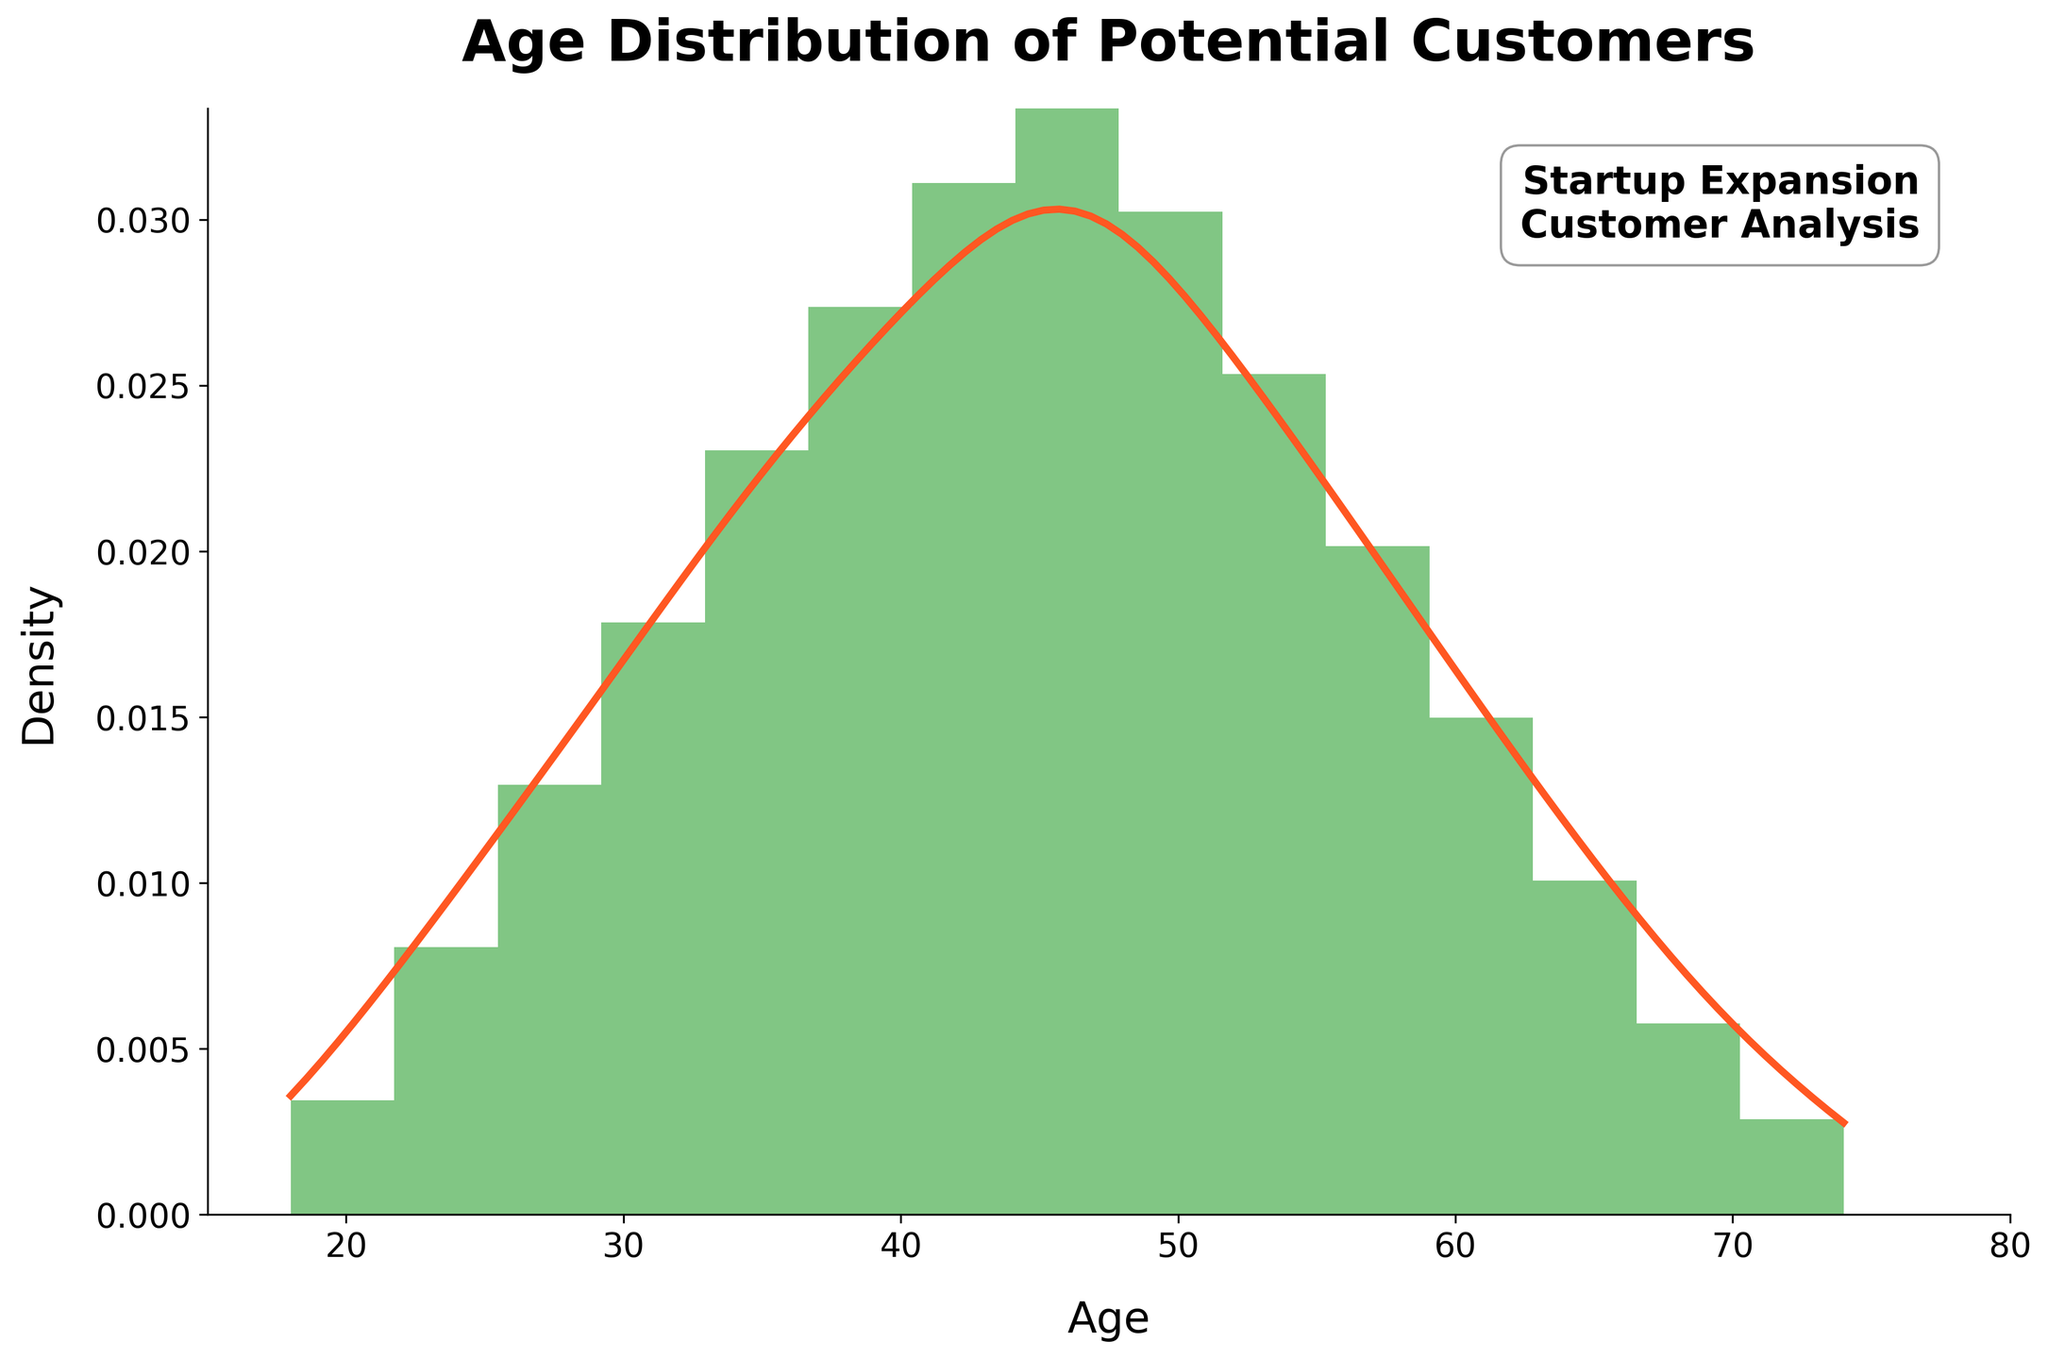What is the title of the chart? The title is usually displayed prominently at the top of the chart. Here, it says "Age Distribution of Potential Customers".
Answer: Age Distribution of Potential Customers What does the x-axis represent? The x-axis label is "Age", indicating it represents the different age groups of potential customers.
Answer: Age What does the y-axis represent? The y-axis is labeled "Density", indicating it represents the density/proportion of potential customers within each age group.
Answer: Density Which age group has the highest density according to the KDE curve? By observing the KDE curve (smooth line), the peak occurs around the age of 46, indicating it has the highest density.
Answer: 46 Approximately how many data points are included in the histogram? The total frequency is the sum of all individual frequencies provided in the data. Adding them up: 12 + 28 + 45 + 62 + 80 + 95 + 108 + 120 + 105 + 88 + 70 + 52 + 35 + 20 + 10 = 930.
Answer: 930 In which age range does the density start decreasing after reaching its peak? By observing the KDE curve, after the peak at around age 46, the density begins to decrease in the age range between 46 and 50.
Answer: 46-50 How does the density at age 30 compare to the density at age 70? The density at age 30 is higher compared to age 70, as observed from the KDE curve. The curve is significantly higher around age 30 and drops off by age 70.
Answer: Higher at age 30 Between ages 42 and 62, which age has the lowest density? Observing the KDE curve within the specified range, age 62 has the lowest density.
Answer: 62 How many age bins are used in the histogram? The histogram displays 15 bins as indicated in the problem statement.
Answer: 15 